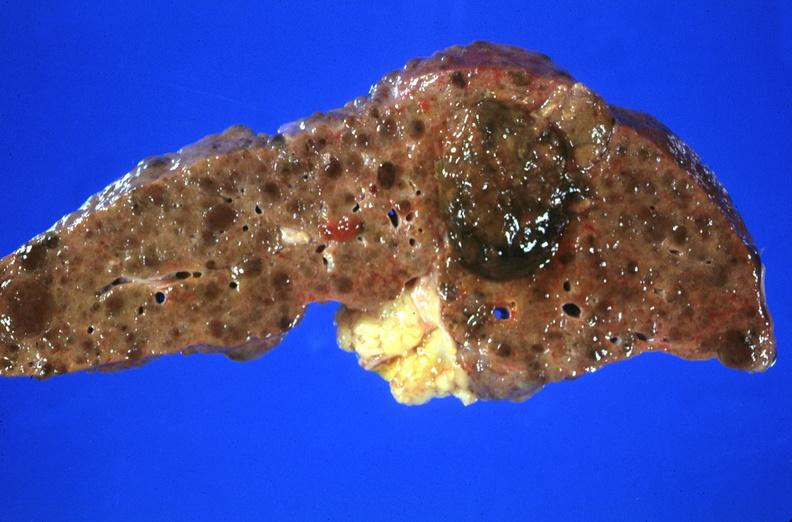does this image show hepatitis b virus, hepatocellular carcinoma?
Answer the question using a single word or phrase. Yes 